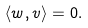<formula> <loc_0><loc_0><loc_500><loc_500>\langle w , v \rangle = 0 .</formula> 